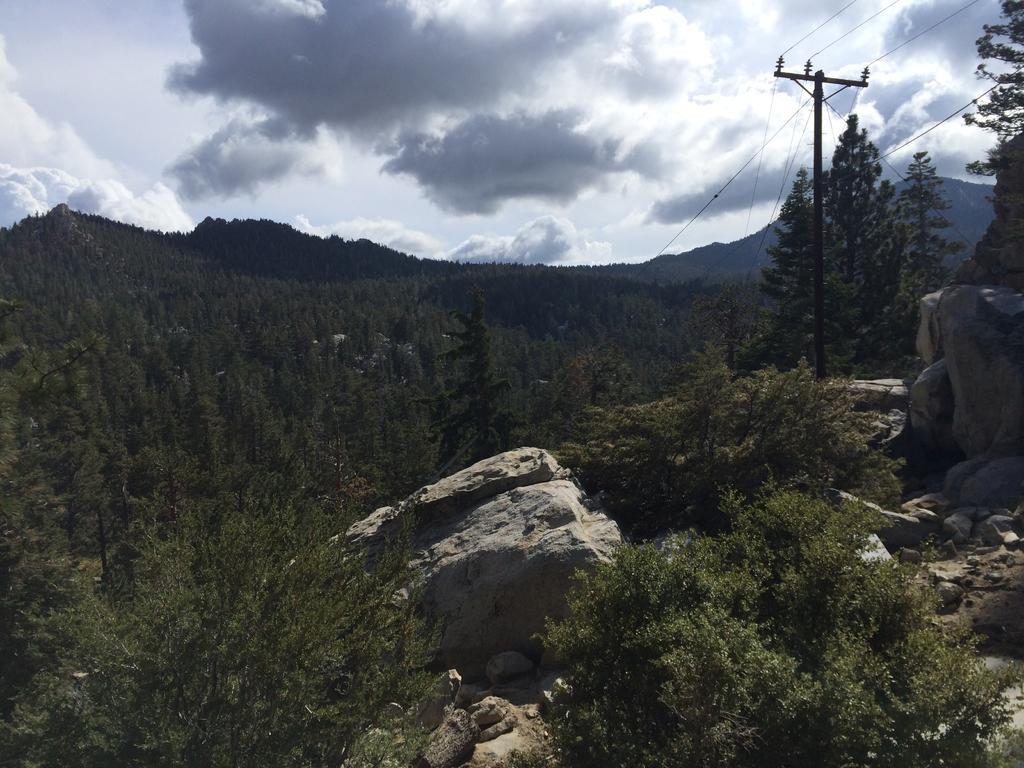Describe this image in one or two sentences. In this image we can see sky with clouds, trees, rocks, electric poles, electric cables and stones. 